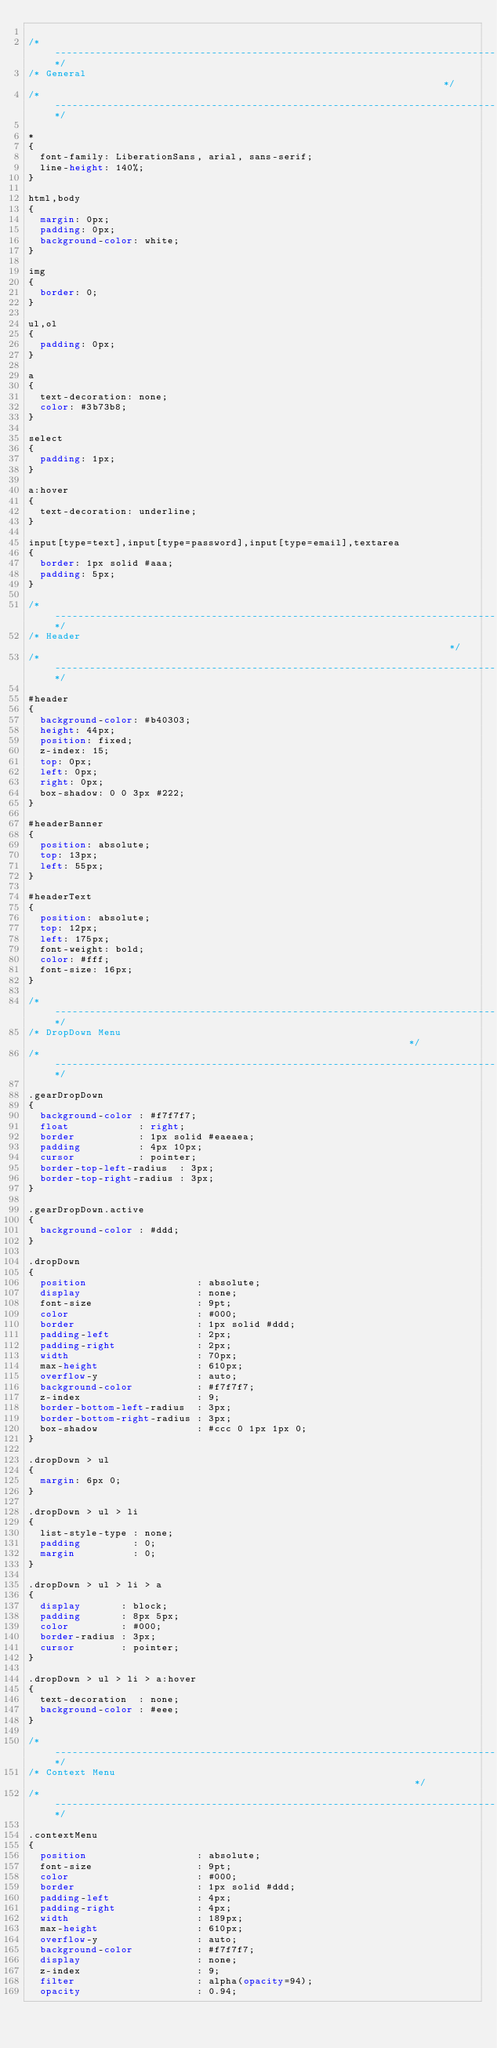<code> <loc_0><loc_0><loc_500><loc_500><_CSS_>
/*----------------------------------------------------------------------------*/
/* General                                                                    */
/*----------------------------------------------------------------------------*/

* 
{
  font-family: LiberationSans, arial, sans-serif;
  line-height: 140%;
}

html,body 
{
  margin: 0px;
  padding: 0px;
  background-color: white;
}

img 
{
  border: 0;
}

ul,ol 
{
  padding: 0px;
}

a
{
  text-decoration: none;
  color: #3b73b8;
}

select
{
  padding: 1px;
}

a:hover
{
  text-decoration: underline;
}

input[type=text],input[type=password],input[type=email],textarea
{
  border: 1px solid #aaa;
  padding: 5px;
}

/*----------------------------------------------------------------------------*/
/* Header                                                                     */
/*----------------------------------------------------------------------------*/

#header
{
  background-color: #b40303;
  height: 44px;
  position: fixed;
  z-index: 15;
  top: 0px;
  left: 0px;
  right: 0px;
  box-shadow: 0 0 3px #222;
}

#headerBanner
{
  position: absolute;
  top: 13px;
  left: 55px;
}

#headerText
{
  position: absolute;
  top: 12px;
  left: 175px;
  font-weight: bold;
  color: #fff;
  font-size: 16px;
}

/*----------------------------------------------------------------------------*/
/* DropDown Menu                                                              */
/*----------------------------------------------------------------------------*/

.gearDropDown 
{
  background-color : #f7f7f7;
  float            : right;
  border           : 1px solid #eaeaea;
  padding          : 4px 10px;
  cursor           : pointer;
  border-top-left-radius  : 3px;
  border-top-right-radius : 3px;
}

.gearDropDown.active 
{
  background-color : #ddd;
}

.dropDown 
{
  position                   : absolute;
  display                    : none;
  font-size                  : 9pt;
  color                      : #000;
  border                     : 1px solid #ddd;
  padding-left               : 2px;
  padding-right              : 2px;
  width                      : 70px;
  max-height                 : 610px;
  overflow-y                 : auto;
  background-color           : #f7f7f7;
  z-index                    : 9;
  border-bottom-left-radius  : 3px;
  border-bottom-right-radius : 3px;
  box-shadow                 : #ccc 0 1px 1px 0;
}

.dropDown > ul 
{
  margin: 6px 0;
}

.dropDown > ul > li 
{
  list-style-type : none;
  padding         : 0;
  margin          : 0;
}

.dropDown > ul > li > a 
{
  display       : block;
  padding       : 8px 5px;
  color         : #000;
  border-radius : 3px;
  cursor        : pointer;
}

.dropDown > ul > li > a:hover 
{
  text-decoration  : none;
  background-color : #eee;
}

/*----------------------------------------------------------------------------*/
/* Context Menu                                                               */
/*----------------------------------------------------------------------------*/

.contextMenu 
{
  position                   : absolute;
  font-size                  : 9pt;
  color                      : #000;
  border                     : 1px solid #ddd;
  padding-left               : 4px;
  padding-right              : 4px;
  width                      : 189px;
  max-height                 : 610px;
  overflow-y                 : auto;
  background-color           : #f7f7f7;
  display                    : none;
  z-index                    : 9;
  filter                     : alpha(opacity=94);
  opacity                    : 0.94;</code> 